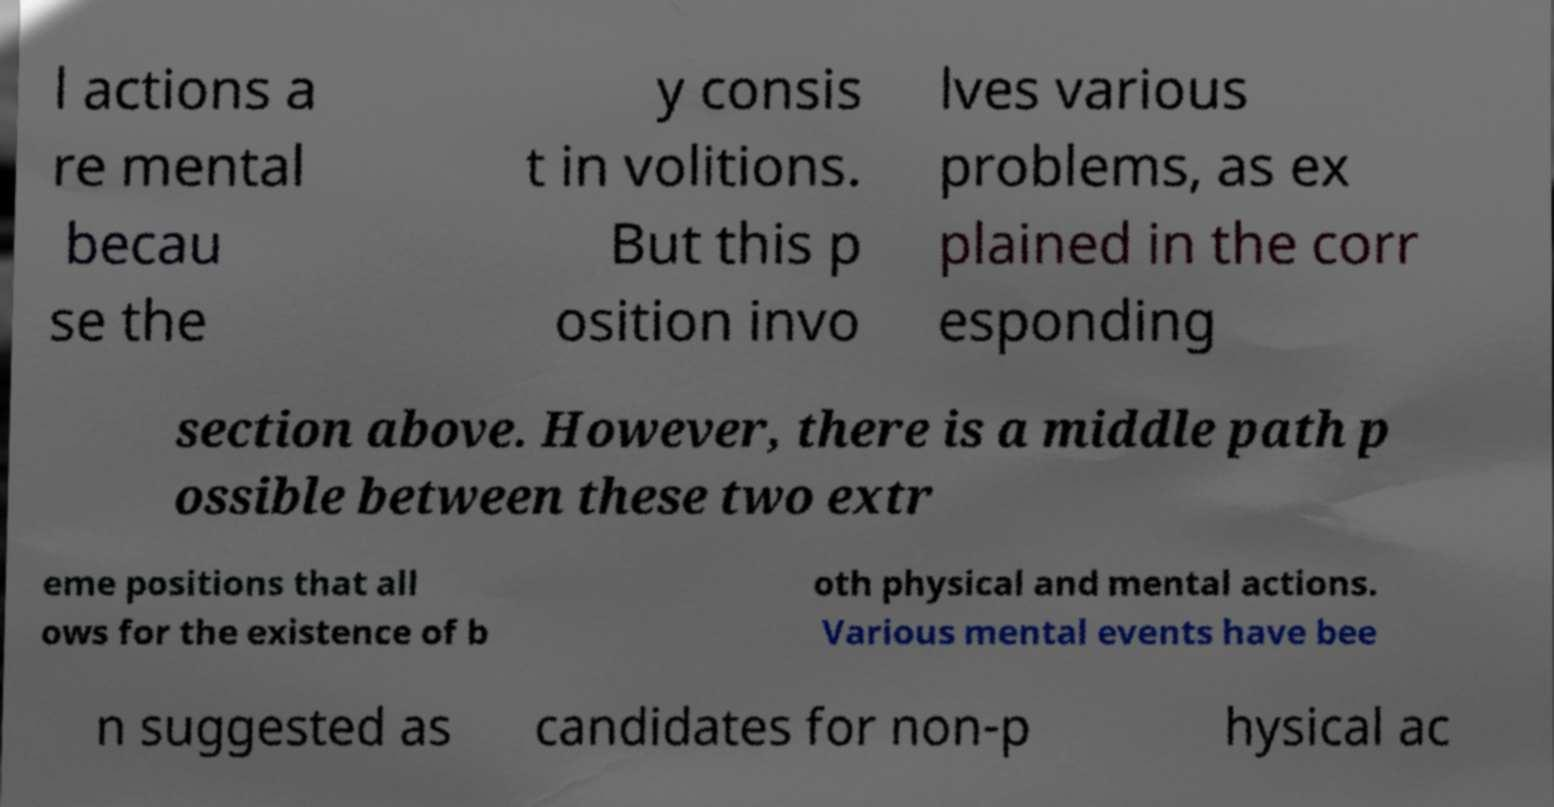Could you extract and type out the text from this image? l actions a re mental becau se the y consis t in volitions. But this p osition invo lves various problems, as ex plained in the corr esponding section above. However, there is a middle path p ossible between these two extr eme positions that all ows for the existence of b oth physical and mental actions. Various mental events have bee n suggested as candidates for non-p hysical ac 